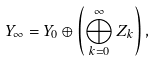<formula> <loc_0><loc_0><loc_500><loc_500>Y _ { \infty } = Y _ { 0 } \oplus \left ( \bigoplus _ { k = 0 } ^ { \infty } Z _ { k } \right ) ,</formula> 